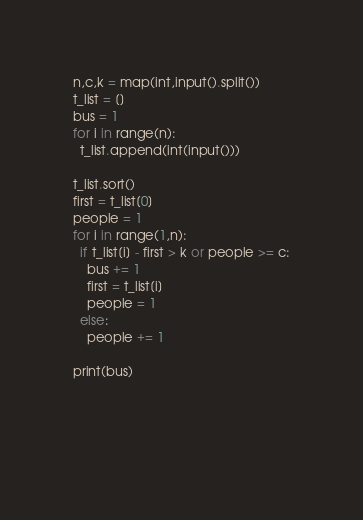Convert code to text. <code><loc_0><loc_0><loc_500><loc_500><_Python_>n,c,k = map(int,input().split())
t_list = []
bus = 1
for i in range(n):
  t_list.append(int(input()))
  
t_list.sort()
first = t_list[0]
people = 1
for i in range(1,n):
  if t_list[i] - first > k or people >= c:
    bus += 1
    first = t_list[i]
    people = 1
  else:
    people += 1
    
print(bus)
    
  
  
  </code> 